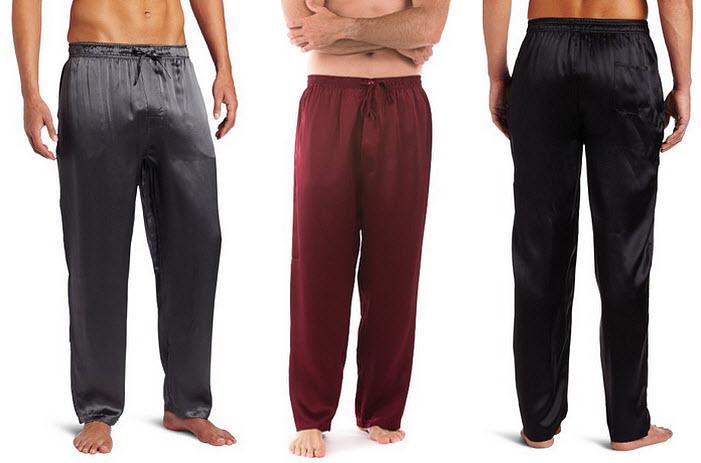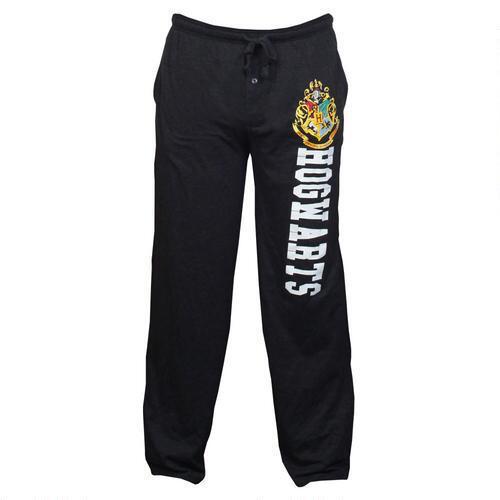The first image is the image on the left, the second image is the image on the right. Given the left and right images, does the statement "There are two pairs of pants" hold true? Answer yes or no. No. 